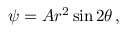Convert formula to latex. <formula><loc_0><loc_0><loc_500><loc_500>\psi = A r ^ { 2 } \sin 2 \theta \, ,</formula> 